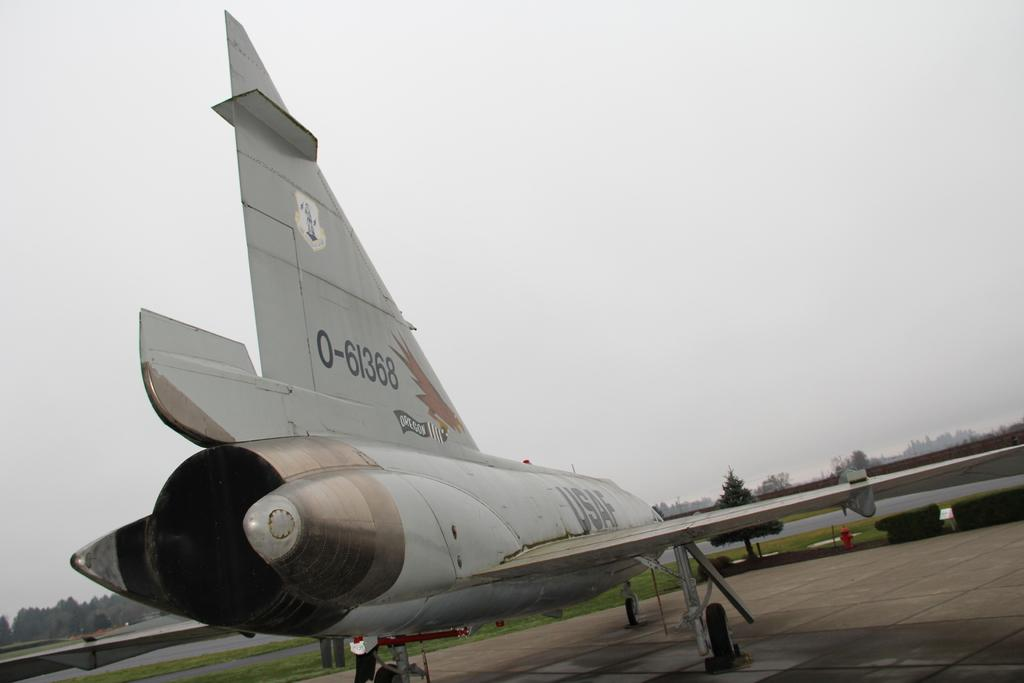<image>
Summarize the visual content of the image. An airplane has the number 61368 on its large tail fin. 